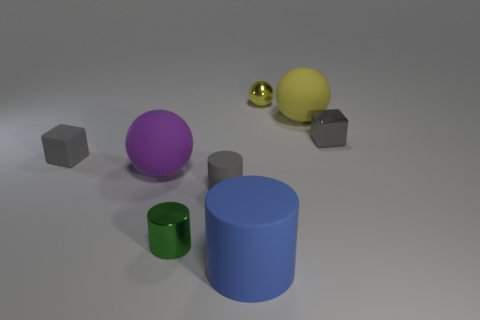Is the number of gray shiny cubes that are on the right side of the small yellow shiny object the same as the number of yellow matte spheres?
Make the answer very short. Yes. What material is the small cube that is in front of the block behind the small gray object that is to the left of the big purple thing?
Your answer should be very brief. Rubber. Is there a cyan rubber cylinder of the same size as the purple matte ball?
Your response must be concise. No. What shape is the tiny yellow metal thing?
Make the answer very short. Sphere. What number of balls are either purple rubber things or yellow things?
Provide a succinct answer. 3. Are there the same number of tiny shiny objects that are left of the small metallic cylinder and objects right of the gray cylinder?
Make the answer very short. No. What number of shiny cylinders are behind the rubber ball that is to the right of the big purple thing in front of the gray shiny thing?
Offer a terse response. 0. What shape is the tiny shiny object that is the same color as the small rubber cube?
Make the answer very short. Cube. There is a tiny metallic block; is it the same color as the tiny cube to the left of the blue thing?
Your answer should be compact. Yes. Are there more gray objects to the left of the yellow rubber sphere than yellow shiny balls?
Keep it short and to the point. Yes. 